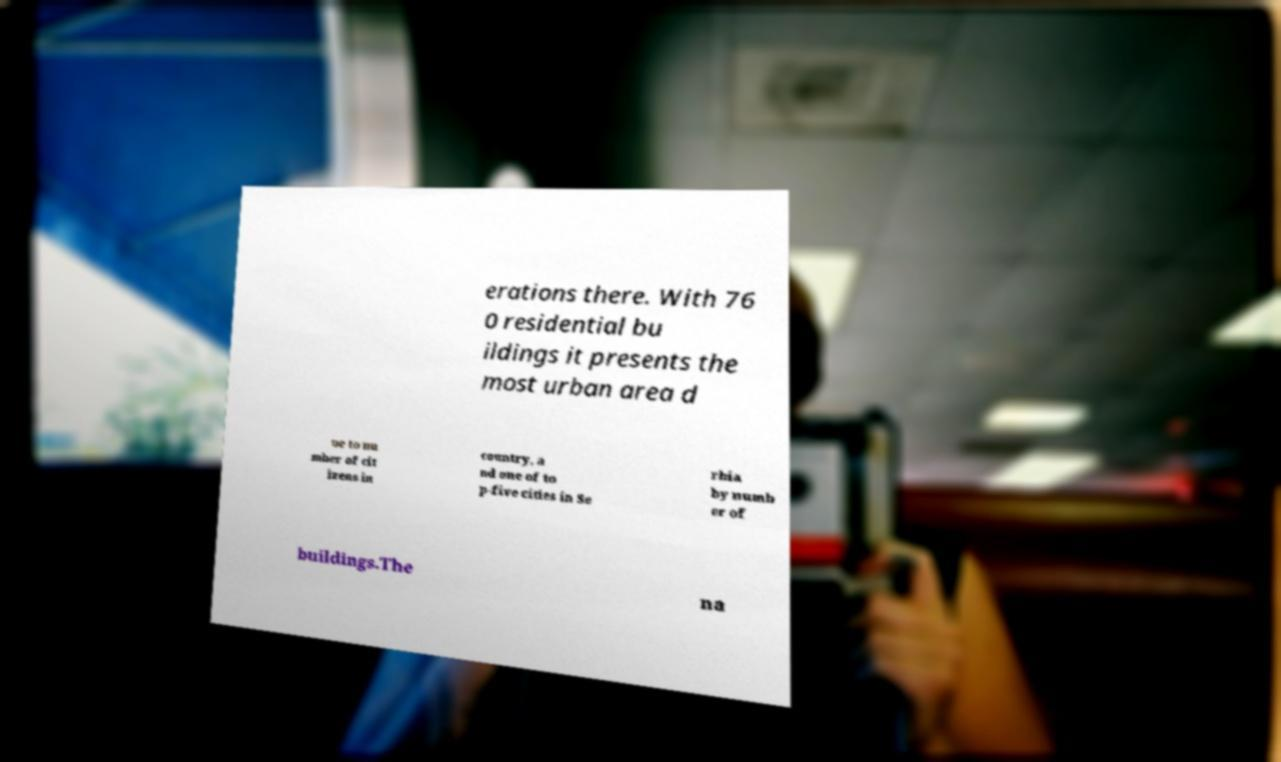There's text embedded in this image that I need extracted. Can you transcribe it verbatim? erations there. With 76 0 residential bu ildings it presents the most urban area d ue to nu mber of cit izens in country, a nd one of to p-five cities in Se rbia by numb er of buildings.The na 